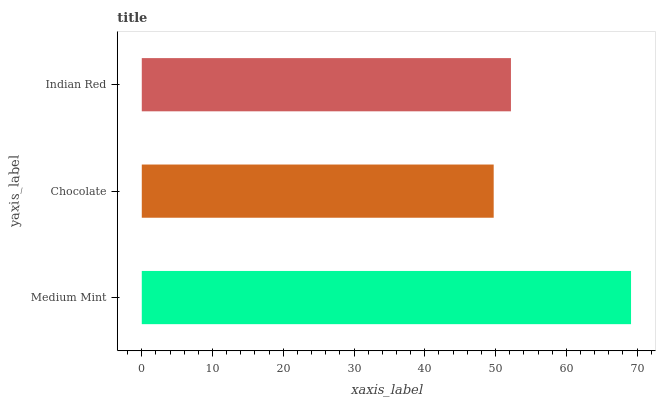Is Chocolate the minimum?
Answer yes or no. Yes. Is Medium Mint the maximum?
Answer yes or no. Yes. Is Indian Red the minimum?
Answer yes or no. No. Is Indian Red the maximum?
Answer yes or no. No. Is Indian Red greater than Chocolate?
Answer yes or no. Yes. Is Chocolate less than Indian Red?
Answer yes or no. Yes. Is Chocolate greater than Indian Red?
Answer yes or no. No. Is Indian Red less than Chocolate?
Answer yes or no. No. Is Indian Red the high median?
Answer yes or no. Yes. Is Indian Red the low median?
Answer yes or no. Yes. Is Medium Mint the high median?
Answer yes or no. No. Is Chocolate the low median?
Answer yes or no. No. 